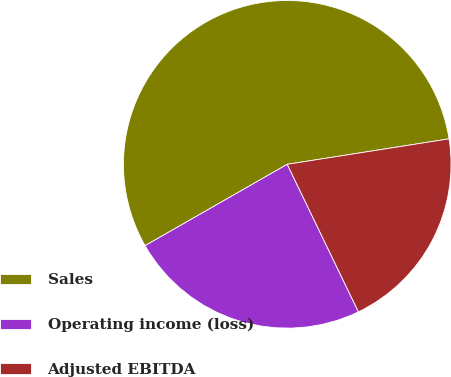Convert chart. <chart><loc_0><loc_0><loc_500><loc_500><pie_chart><fcel>Sales<fcel>Operating income (loss)<fcel>Adjusted EBITDA<nl><fcel>55.79%<fcel>23.88%<fcel>20.33%<nl></chart> 